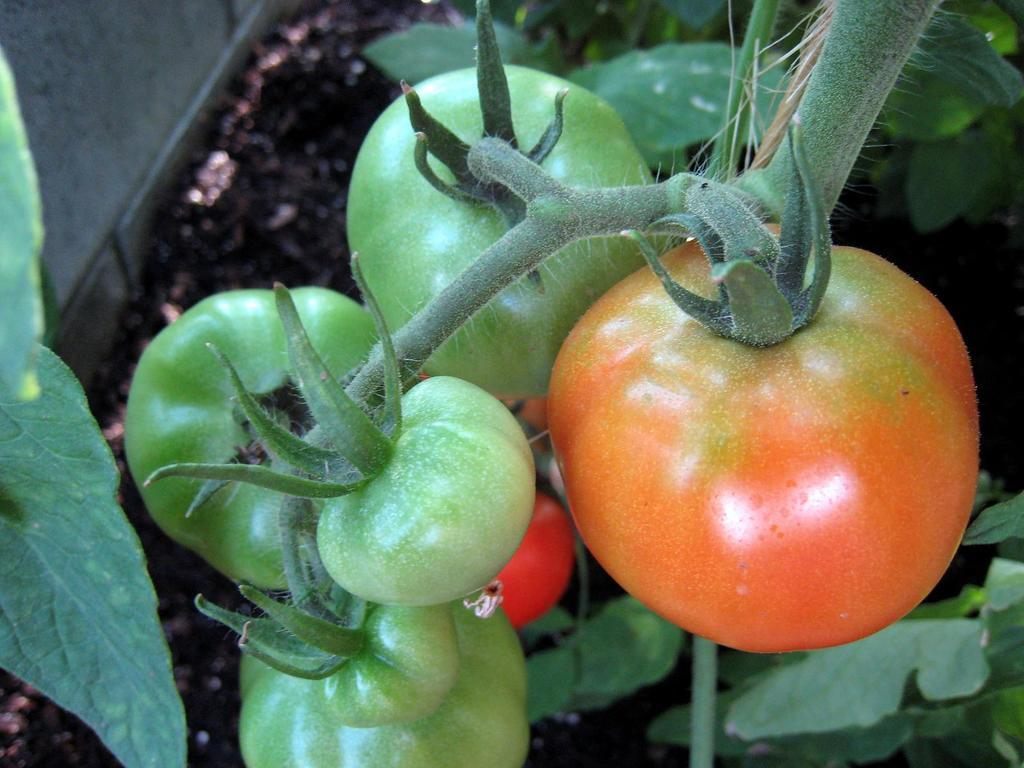What type of fruit can be seen on a stem in the image? There are tomatoes on a stem in the image. What can be seen on the right side of the image? There are plants on the right side of the image. What is present on the left side of the image? There are leaves and a wall on the left side of the image. What type of surface is visible in the image? Soil is visible in the image. What type of ring can be seen on the tomato in the image? There is no ring present on the tomato or any other object in the image. 